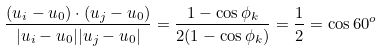Convert formula to latex. <formula><loc_0><loc_0><loc_500><loc_500>\frac { ( u _ { i } - u _ { 0 } ) \cdot ( u _ { j } - u _ { 0 } ) } { | u _ { i } - u _ { 0 } | | u _ { j } - u _ { 0 } | } = \frac { 1 - \cos \phi _ { k } } { 2 ( 1 - \cos \phi _ { k } ) } = \frac { 1 } { 2 } = \cos 6 0 ^ { o }</formula> 